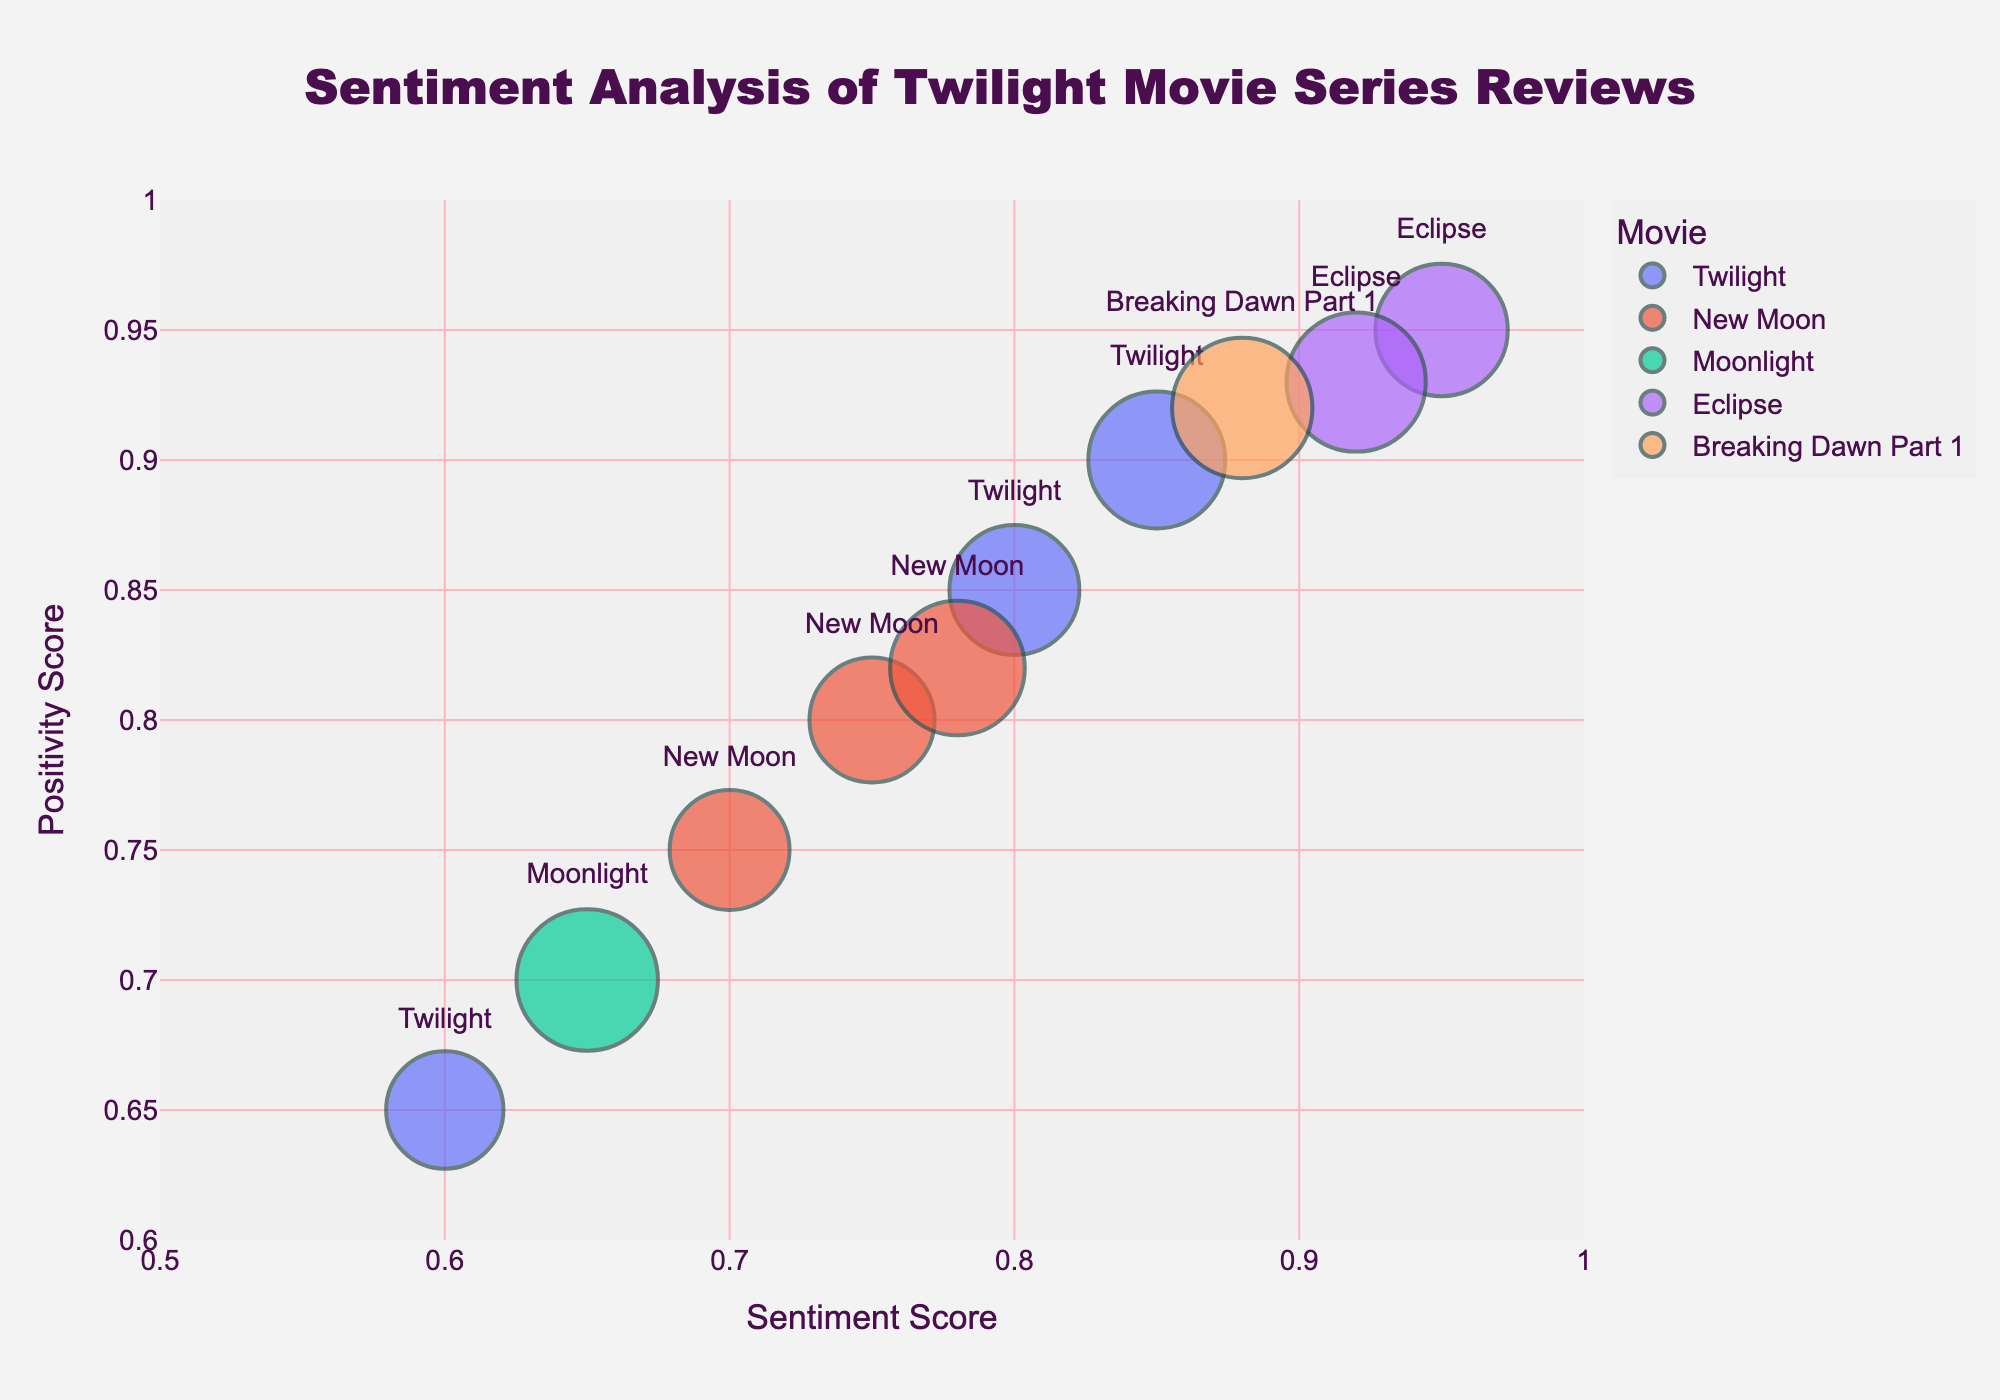Which movie has the highest positivity score? The movie with the highest positivity score can be identified directly from the plot by looking at the y-axis for the highest value and checking the corresponding movie in the legend.
Answer: Eclipse How many reviews have a sentiment score of 0.75 or higher? By examining the x-axis and counting the bubbles to the right of 0.75, we can determine the number of reviews with sentiment scores of 0.75 or higher. There are 7 such reviews.
Answer: 7 Which review has the largest bubble? The size of the bubble represents the review length. The largest bubble can be identified visually by locating the largest sized bubble on the plot. Knowing that 'size_max=50' helps us estimate that it's for "Breaking Dawn Part 1" by PopcornGuru.
Answer: Breaking Dawn Part 1 by PopcornGuru Is there any movie with a bubble in the top-right corner of the plot? The top-right corner of the plot has high sentiment and positivity scores, near the (1,1) mark. Review the plot to see if any movie's bubble is located in that area.
Answer: Yes, Eclipse Between "Twilight" and "New Moon," which has more positive reviews on average? To find this, we need to average the positivity scores for "Twilight" reviews and "New Moon" reviews from the y-axis values and compare them. Twilight has scores 0.9, 0.85, 0.65 so the average is (0.9+0.85+0.65)/3 = 0.80. New Moon has scores 0.8, 0.75, 0.82 so the average is (0.8 + 0.75 + 0.82)/3 = 0.79. Hence, Twilight has more positive reviews on average.
Answer: Twilight Which cinema buff has given the most positive review for "Eclipse"? By examining the plot for the bubbles corresponding to the movie "Eclipse" and looking at the y-axis for the highest positivity score, we see the name in the hover text.
Answer: FlicksAndChill Which review has the lowest positivity score? The lowest positivity score can be identified by finding the smallest y-value on the plot. This corresponds to the review for "Twilight" by MovieMania.
Answer: Twilight by MovieMania What’s the average sentiment score for all reviews? Add all sentiment scores (0.85+0.75+0.65+0.95+0.80+0.70+0.88+0.60+0.78+0.92) and divide by the number of reviews, which is 10. (0.85 + 0.75 + 0.65 + 0.95 + 0.80 + 0.70 + 0.88 + 0.60 + 0.78 + 0.92) / 10 = 7.78/10 = 0.778
Answer: 0.778 